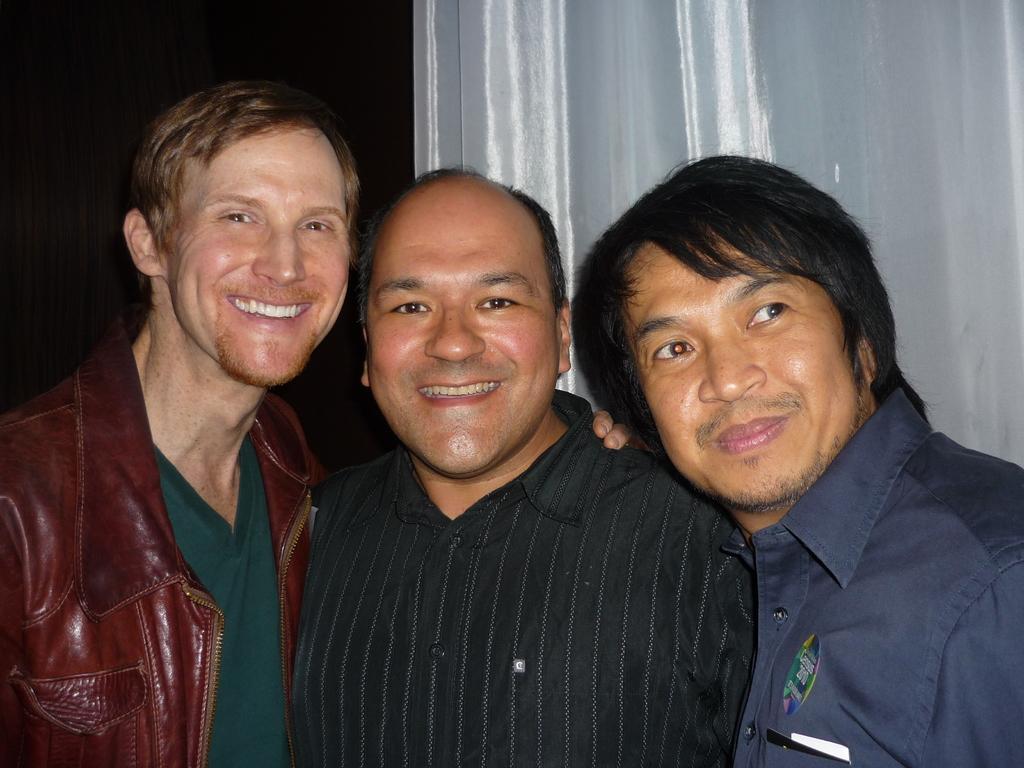Describe this image in one or two sentences. In this picture I can see three men are standing together and smiling. The two persons are wearing shirt and the person on the left side is wearing a jacket. 